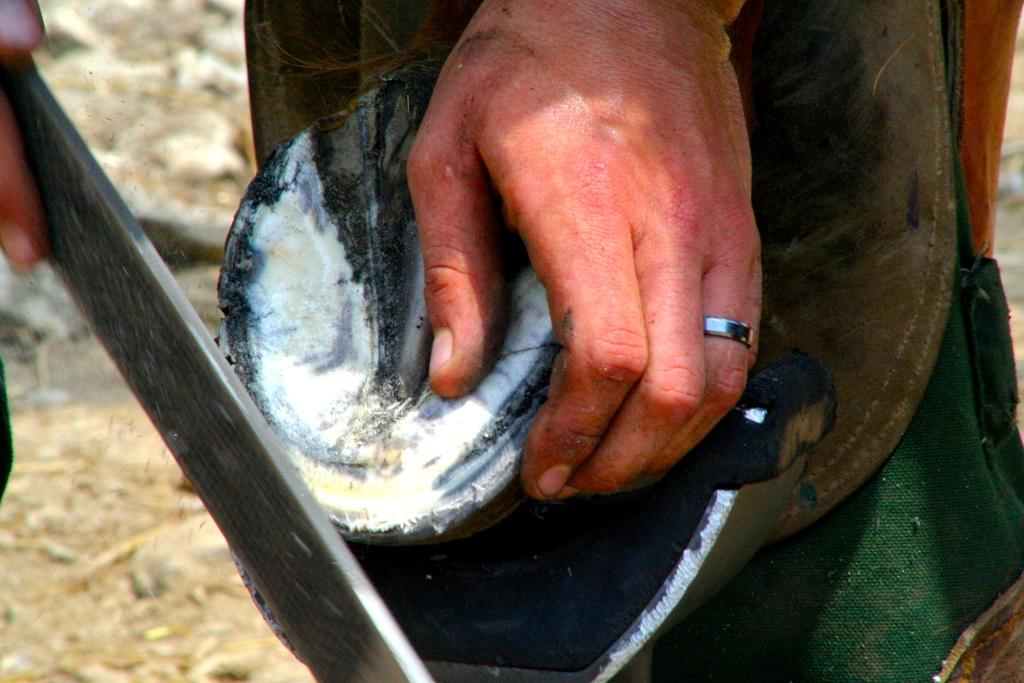What can be seen in the image related to a person? There are hands of a person in the image. What is the person holding in their hands? There are objects in the hands of the person. Can you describe the background of the image? The background of the image is blurred. What type of rail can be seen in the image? There is no rail present in the image. What is the person's need for the objects they are holding in the image? The image does not provide information about the person's need for the objects they are holding. 